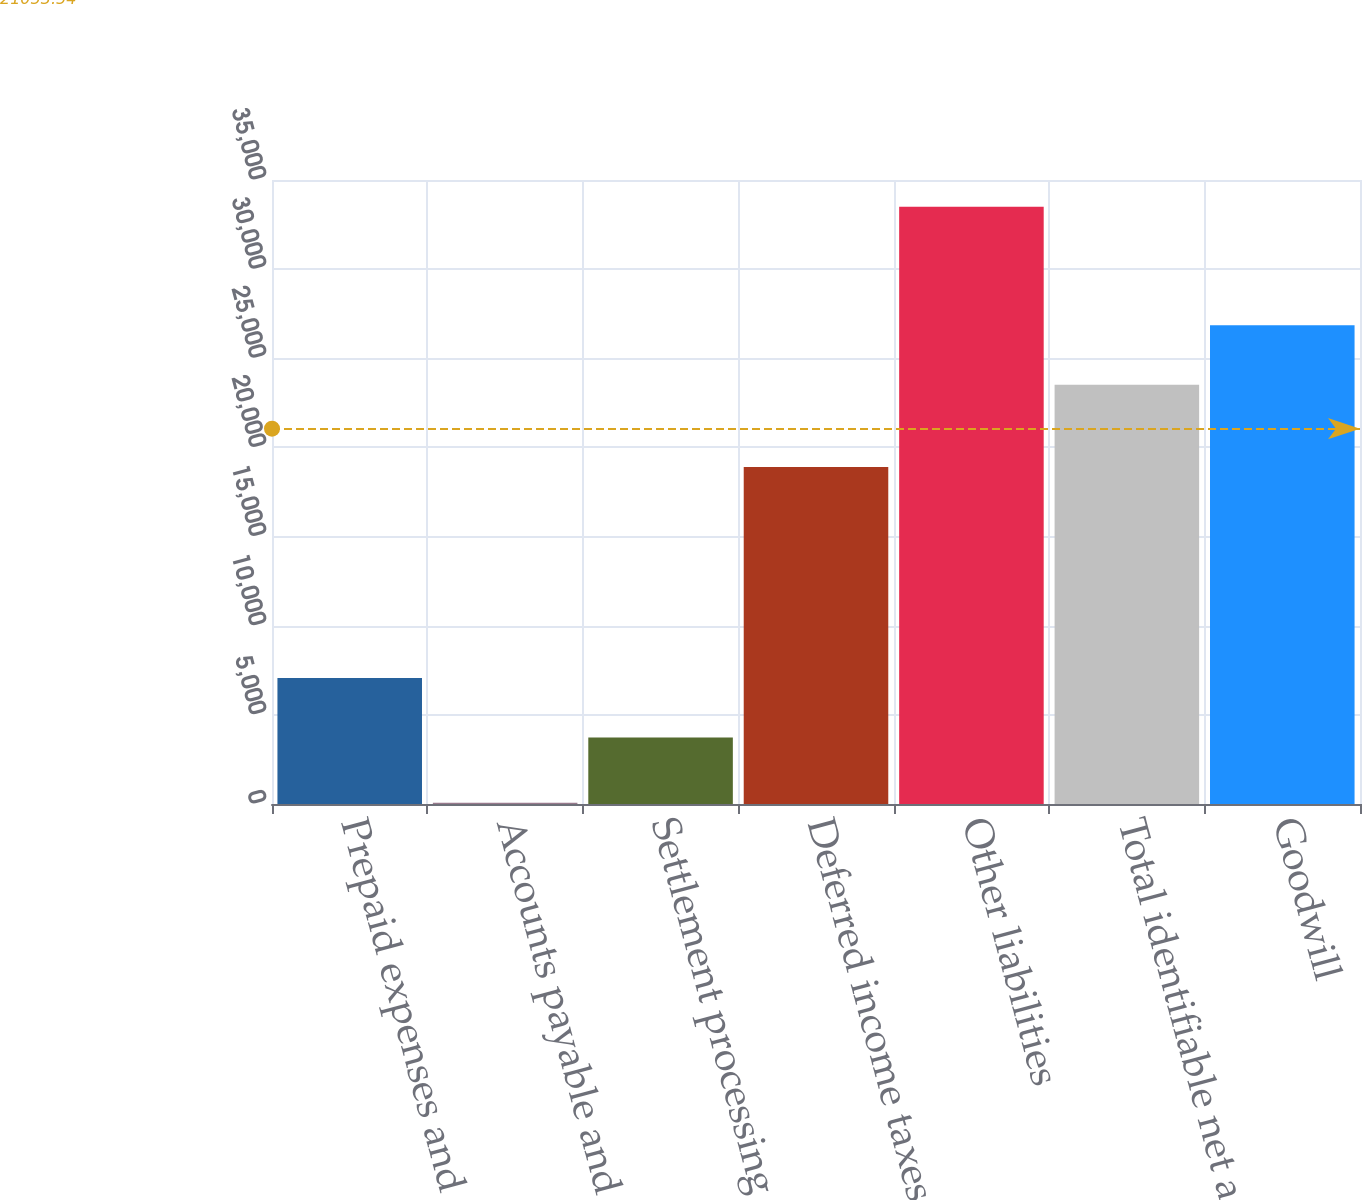<chart> <loc_0><loc_0><loc_500><loc_500><bar_chart><fcel>Prepaid expenses and other<fcel>Accounts payable and accrued<fcel>Settlement processing<fcel>Deferred income taxes<fcel>Other liabilities<fcel>Total identifiable net assets<fcel>Goodwill<nl><fcel>7070<fcel>65<fcel>3727<fcel>18907<fcel>33495<fcel>23511<fcel>26854<nl></chart> 